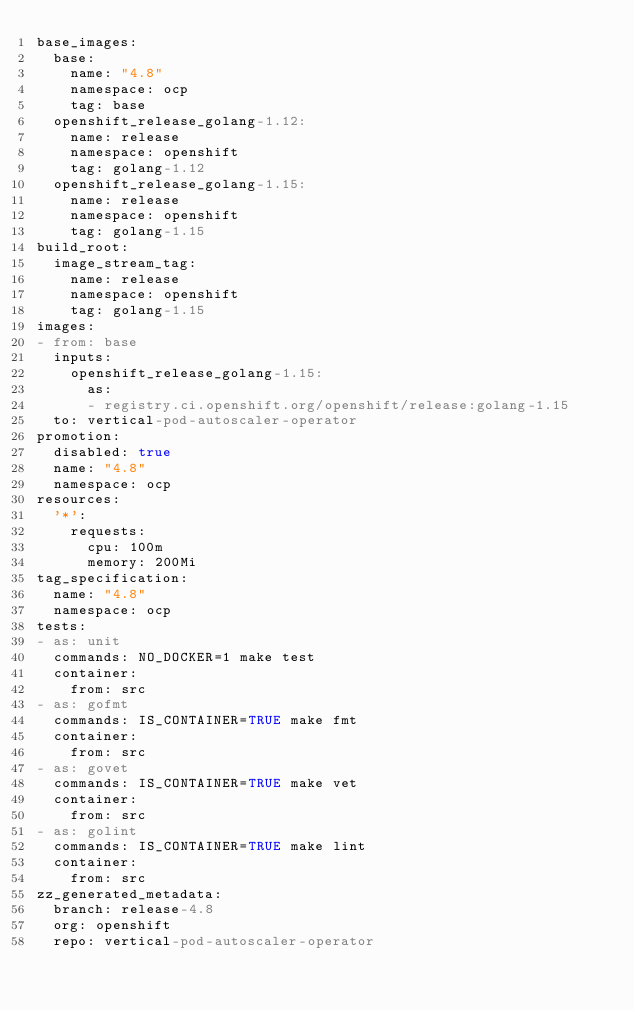Convert code to text. <code><loc_0><loc_0><loc_500><loc_500><_YAML_>base_images:
  base:
    name: "4.8"
    namespace: ocp
    tag: base
  openshift_release_golang-1.12:
    name: release
    namespace: openshift
    tag: golang-1.12
  openshift_release_golang-1.15:
    name: release
    namespace: openshift
    tag: golang-1.15
build_root:
  image_stream_tag:
    name: release
    namespace: openshift
    tag: golang-1.15
images:
- from: base
  inputs:
    openshift_release_golang-1.15:
      as:
      - registry.ci.openshift.org/openshift/release:golang-1.15
  to: vertical-pod-autoscaler-operator
promotion:
  disabled: true
  name: "4.8"
  namespace: ocp
resources:
  '*':
    requests:
      cpu: 100m
      memory: 200Mi
tag_specification:
  name: "4.8"
  namespace: ocp
tests:
- as: unit
  commands: NO_DOCKER=1 make test
  container:
    from: src
- as: gofmt
  commands: IS_CONTAINER=TRUE make fmt
  container:
    from: src
- as: govet
  commands: IS_CONTAINER=TRUE make vet
  container:
    from: src
- as: golint
  commands: IS_CONTAINER=TRUE make lint
  container:
    from: src
zz_generated_metadata:
  branch: release-4.8
  org: openshift
  repo: vertical-pod-autoscaler-operator
</code> 